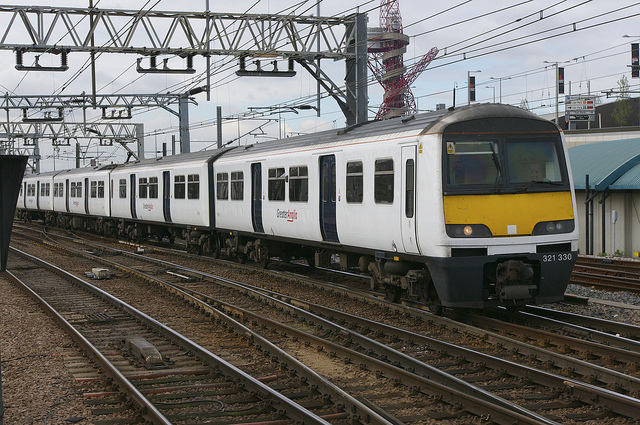<image>Why is the train at platform 5? It is unknown why the train is at platform 5. It could be waiting for passengers or because of its schedule. Why is the train at platform 5? I don't know why the train is at platform 5. It can be for various reasons such as waiting for passengers, loading, or because of the schedule. 